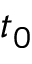<formula> <loc_0><loc_0><loc_500><loc_500>t _ { 0 }</formula> 